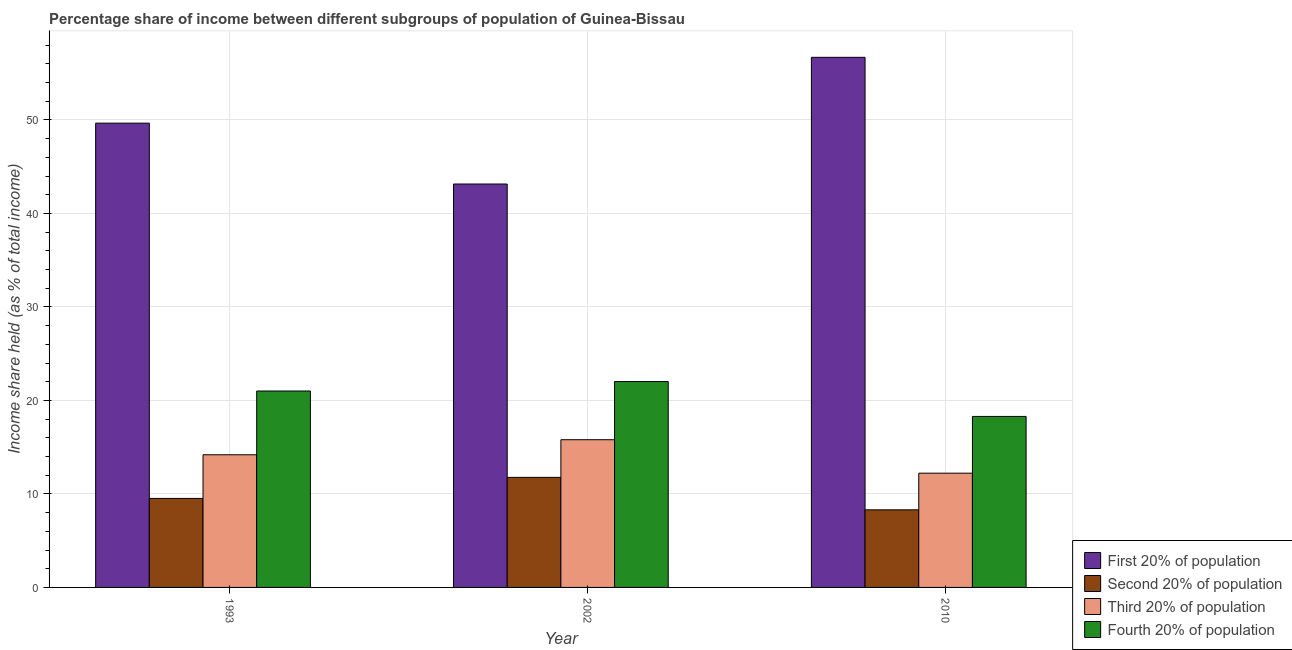How many different coloured bars are there?
Make the answer very short. 4. Are the number of bars per tick equal to the number of legend labels?
Offer a very short reply. Yes. Are the number of bars on each tick of the X-axis equal?
Offer a terse response. Yes. How many bars are there on the 2nd tick from the right?
Give a very brief answer. 4. In how many cases, is the number of bars for a given year not equal to the number of legend labels?
Offer a terse response. 0. What is the share of the income held by first 20% of the population in 2002?
Keep it short and to the point. 43.15. Across all years, what is the maximum share of the income held by first 20% of the population?
Offer a terse response. 56.7. Across all years, what is the minimum share of the income held by fourth 20% of the population?
Your response must be concise. 18.29. In which year was the share of the income held by second 20% of the population minimum?
Offer a very short reply. 2010. What is the total share of the income held by second 20% of the population in the graph?
Provide a short and direct response. 29.59. What is the difference between the share of the income held by fourth 20% of the population in 1993 and that in 2010?
Your answer should be compact. 2.72. What is the difference between the share of the income held by fourth 20% of the population in 2010 and the share of the income held by third 20% of the population in 2002?
Your answer should be compact. -3.73. What is the average share of the income held by second 20% of the population per year?
Keep it short and to the point. 9.86. In the year 2010, what is the difference between the share of the income held by third 20% of the population and share of the income held by fourth 20% of the population?
Make the answer very short. 0. What is the ratio of the share of the income held by third 20% of the population in 1993 to that in 2002?
Offer a terse response. 0.9. What is the difference between the highest and the second highest share of the income held by third 20% of the population?
Your response must be concise. 1.61. What is the difference between the highest and the lowest share of the income held by first 20% of the population?
Ensure brevity in your answer.  13.55. Is the sum of the share of the income held by second 20% of the population in 2002 and 2010 greater than the maximum share of the income held by third 20% of the population across all years?
Make the answer very short. Yes. What does the 4th bar from the left in 2002 represents?
Ensure brevity in your answer.  Fourth 20% of population. What does the 1st bar from the right in 1993 represents?
Ensure brevity in your answer.  Fourth 20% of population. Is it the case that in every year, the sum of the share of the income held by first 20% of the population and share of the income held by second 20% of the population is greater than the share of the income held by third 20% of the population?
Offer a terse response. Yes. How many bars are there?
Provide a short and direct response. 12. Are all the bars in the graph horizontal?
Offer a terse response. No. Are the values on the major ticks of Y-axis written in scientific E-notation?
Make the answer very short. No. Does the graph contain any zero values?
Your response must be concise. No. Does the graph contain grids?
Offer a terse response. Yes. Where does the legend appear in the graph?
Give a very brief answer. Bottom right. How many legend labels are there?
Offer a very short reply. 4. How are the legend labels stacked?
Provide a short and direct response. Vertical. What is the title of the graph?
Keep it short and to the point. Percentage share of income between different subgroups of population of Guinea-Bissau. Does "Quality of public administration" appear as one of the legend labels in the graph?
Give a very brief answer. No. What is the label or title of the X-axis?
Make the answer very short. Year. What is the label or title of the Y-axis?
Give a very brief answer. Income share held (as % of total income). What is the Income share held (as % of total income) of First 20% of population in 1993?
Offer a terse response. 49.66. What is the Income share held (as % of total income) in Second 20% of population in 1993?
Provide a succinct answer. 9.52. What is the Income share held (as % of total income) in Third 20% of population in 1993?
Give a very brief answer. 14.19. What is the Income share held (as % of total income) in Fourth 20% of population in 1993?
Your answer should be very brief. 21.01. What is the Income share held (as % of total income) in First 20% of population in 2002?
Offer a terse response. 43.15. What is the Income share held (as % of total income) in Second 20% of population in 2002?
Keep it short and to the point. 11.77. What is the Income share held (as % of total income) in Third 20% of population in 2002?
Provide a succinct answer. 15.8. What is the Income share held (as % of total income) of Fourth 20% of population in 2002?
Make the answer very short. 22.02. What is the Income share held (as % of total income) in First 20% of population in 2010?
Offer a very short reply. 56.7. What is the Income share held (as % of total income) in Second 20% of population in 2010?
Your response must be concise. 8.3. What is the Income share held (as % of total income) of Third 20% of population in 2010?
Provide a short and direct response. 12.22. What is the Income share held (as % of total income) in Fourth 20% of population in 2010?
Make the answer very short. 18.29. Across all years, what is the maximum Income share held (as % of total income) of First 20% of population?
Give a very brief answer. 56.7. Across all years, what is the maximum Income share held (as % of total income) of Second 20% of population?
Provide a short and direct response. 11.77. Across all years, what is the maximum Income share held (as % of total income) in Fourth 20% of population?
Keep it short and to the point. 22.02. Across all years, what is the minimum Income share held (as % of total income) in First 20% of population?
Your answer should be very brief. 43.15. Across all years, what is the minimum Income share held (as % of total income) in Second 20% of population?
Your response must be concise. 8.3. Across all years, what is the minimum Income share held (as % of total income) in Third 20% of population?
Provide a succinct answer. 12.22. Across all years, what is the minimum Income share held (as % of total income) in Fourth 20% of population?
Ensure brevity in your answer.  18.29. What is the total Income share held (as % of total income) of First 20% of population in the graph?
Make the answer very short. 149.51. What is the total Income share held (as % of total income) of Second 20% of population in the graph?
Provide a short and direct response. 29.59. What is the total Income share held (as % of total income) in Third 20% of population in the graph?
Give a very brief answer. 42.21. What is the total Income share held (as % of total income) in Fourth 20% of population in the graph?
Offer a terse response. 61.32. What is the difference between the Income share held (as % of total income) of First 20% of population in 1993 and that in 2002?
Offer a terse response. 6.51. What is the difference between the Income share held (as % of total income) of Second 20% of population in 1993 and that in 2002?
Provide a short and direct response. -2.25. What is the difference between the Income share held (as % of total income) of Third 20% of population in 1993 and that in 2002?
Make the answer very short. -1.61. What is the difference between the Income share held (as % of total income) of Fourth 20% of population in 1993 and that in 2002?
Your answer should be very brief. -1.01. What is the difference between the Income share held (as % of total income) of First 20% of population in 1993 and that in 2010?
Your answer should be very brief. -7.04. What is the difference between the Income share held (as % of total income) of Second 20% of population in 1993 and that in 2010?
Give a very brief answer. 1.22. What is the difference between the Income share held (as % of total income) of Third 20% of population in 1993 and that in 2010?
Offer a terse response. 1.97. What is the difference between the Income share held (as % of total income) of Fourth 20% of population in 1993 and that in 2010?
Offer a terse response. 2.72. What is the difference between the Income share held (as % of total income) of First 20% of population in 2002 and that in 2010?
Provide a succinct answer. -13.55. What is the difference between the Income share held (as % of total income) in Second 20% of population in 2002 and that in 2010?
Your answer should be very brief. 3.47. What is the difference between the Income share held (as % of total income) of Third 20% of population in 2002 and that in 2010?
Keep it short and to the point. 3.58. What is the difference between the Income share held (as % of total income) of Fourth 20% of population in 2002 and that in 2010?
Your response must be concise. 3.73. What is the difference between the Income share held (as % of total income) in First 20% of population in 1993 and the Income share held (as % of total income) in Second 20% of population in 2002?
Offer a terse response. 37.89. What is the difference between the Income share held (as % of total income) in First 20% of population in 1993 and the Income share held (as % of total income) in Third 20% of population in 2002?
Give a very brief answer. 33.86. What is the difference between the Income share held (as % of total income) in First 20% of population in 1993 and the Income share held (as % of total income) in Fourth 20% of population in 2002?
Give a very brief answer. 27.64. What is the difference between the Income share held (as % of total income) in Second 20% of population in 1993 and the Income share held (as % of total income) in Third 20% of population in 2002?
Give a very brief answer. -6.28. What is the difference between the Income share held (as % of total income) in Second 20% of population in 1993 and the Income share held (as % of total income) in Fourth 20% of population in 2002?
Provide a short and direct response. -12.5. What is the difference between the Income share held (as % of total income) of Third 20% of population in 1993 and the Income share held (as % of total income) of Fourth 20% of population in 2002?
Offer a terse response. -7.83. What is the difference between the Income share held (as % of total income) of First 20% of population in 1993 and the Income share held (as % of total income) of Second 20% of population in 2010?
Make the answer very short. 41.36. What is the difference between the Income share held (as % of total income) of First 20% of population in 1993 and the Income share held (as % of total income) of Third 20% of population in 2010?
Offer a terse response. 37.44. What is the difference between the Income share held (as % of total income) in First 20% of population in 1993 and the Income share held (as % of total income) in Fourth 20% of population in 2010?
Your answer should be compact. 31.37. What is the difference between the Income share held (as % of total income) of Second 20% of population in 1993 and the Income share held (as % of total income) of Fourth 20% of population in 2010?
Give a very brief answer. -8.77. What is the difference between the Income share held (as % of total income) in First 20% of population in 2002 and the Income share held (as % of total income) in Second 20% of population in 2010?
Offer a very short reply. 34.85. What is the difference between the Income share held (as % of total income) of First 20% of population in 2002 and the Income share held (as % of total income) of Third 20% of population in 2010?
Make the answer very short. 30.93. What is the difference between the Income share held (as % of total income) in First 20% of population in 2002 and the Income share held (as % of total income) in Fourth 20% of population in 2010?
Offer a terse response. 24.86. What is the difference between the Income share held (as % of total income) of Second 20% of population in 2002 and the Income share held (as % of total income) of Third 20% of population in 2010?
Offer a very short reply. -0.45. What is the difference between the Income share held (as % of total income) of Second 20% of population in 2002 and the Income share held (as % of total income) of Fourth 20% of population in 2010?
Make the answer very short. -6.52. What is the difference between the Income share held (as % of total income) of Third 20% of population in 2002 and the Income share held (as % of total income) of Fourth 20% of population in 2010?
Your response must be concise. -2.49. What is the average Income share held (as % of total income) in First 20% of population per year?
Ensure brevity in your answer.  49.84. What is the average Income share held (as % of total income) of Second 20% of population per year?
Your answer should be compact. 9.86. What is the average Income share held (as % of total income) in Third 20% of population per year?
Offer a terse response. 14.07. What is the average Income share held (as % of total income) in Fourth 20% of population per year?
Provide a short and direct response. 20.44. In the year 1993, what is the difference between the Income share held (as % of total income) in First 20% of population and Income share held (as % of total income) in Second 20% of population?
Keep it short and to the point. 40.14. In the year 1993, what is the difference between the Income share held (as % of total income) of First 20% of population and Income share held (as % of total income) of Third 20% of population?
Offer a terse response. 35.47. In the year 1993, what is the difference between the Income share held (as % of total income) of First 20% of population and Income share held (as % of total income) of Fourth 20% of population?
Offer a very short reply. 28.65. In the year 1993, what is the difference between the Income share held (as % of total income) in Second 20% of population and Income share held (as % of total income) in Third 20% of population?
Give a very brief answer. -4.67. In the year 1993, what is the difference between the Income share held (as % of total income) in Second 20% of population and Income share held (as % of total income) in Fourth 20% of population?
Your response must be concise. -11.49. In the year 1993, what is the difference between the Income share held (as % of total income) of Third 20% of population and Income share held (as % of total income) of Fourth 20% of population?
Ensure brevity in your answer.  -6.82. In the year 2002, what is the difference between the Income share held (as % of total income) of First 20% of population and Income share held (as % of total income) of Second 20% of population?
Offer a terse response. 31.38. In the year 2002, what is the difference between the Income share held (as % of total income) of First 20% of population and Income share held (as % of total income) of Third 20% of population?
Your answer should be very brief. 27.35. In the year 2002, what is the difference between the Income share held (as % of total income) of First 20% of population and Income share held (as % of total income) of Fourth 20% of population?
Your response must be concise. 21.13. In the year 2002, what is the difference between the Income share held (as % of total income) in Second 20% of population and Income share held (as % of total income) in Third 20% of population?
Your response must be concise. -4.03. In the year 2002, what is the difference between the Income share held (as % of total income) in Second 20% of population and Income share held (as % of total income) in Fourth 20% of population?
Your answer should be compact. -10.25. In the year 2002, what is the difference between the Income share held (as % of total income) of Third 20% of population and Income share held (as % of total income) of Fourth 20% of population?
Your answer should be compact. -6.22. In the year 2010, what is the difference between the Income share held (as % of total income) in First 20% of population and Income share held (as % of total income) in Second 20% of population?
Make the answer very short. 48.4. In the year 2010, what is the difference between the Income share held (as % of total income) in First 20% of population and Income share held (as % of total income) in Third 20% of population?
Provide a short and direct response. 44.48. In the year 2010, what is the difference between the Income share held (as % of total income) of First 20% of population and Income share held (as % of total income) of Fourth 20% of population?
Provide a short and direct response. 38.41. In the year 2010, what is the difference between the Income share held (as % of total income) in Second 20% of population and Income share held (as % of total income) in Third 20% of population?
Offer a very short reply. -3.92. In the year 2010, what is the difference between the Income share held (as % of total income) of Second 20% of population and Income share held (as % of total income) of Fourth 20% of population?
Your response must be concise. -9.99. In the year 2010, what is the difference between the Income share held (as % of total income) in Third 20% of population and Income share held (as % of total income) in Fourth 20% of population?
Give a very brief answer. -6.07. What is the ratio of the Income share held (as % of total income) in First 20% of population in 1993 to that in 2002?
Your response must be concise. 1.15. What is the ratio of the Income share held (as % of total income) in Second 20% of population in 1993 to that in 2002?
Your response must be concise. 0.81. What is the ratio of the Income share held (as % of total income) of Third 20% of population in 1993 to that in 2002?
Your answer should be very brief. 0.9. What is the ratio of the Income share held (as % of total income) in Fourth 20% of population in 1993 to that in 2002?
Offer a very short reply. 0.95. What is the ratio of the Income share held (as % of total income) of First 20% of population in 1993 to that in 2010?
Make the answer very short. 0.88. What is the ratio of the Income share held (as % of total income) in Second 20% of population in 1993 to that in 2010?
Your answer should be compact. 1.15. What is the ratio of the Income share held (as % of total income) of Third 20% of population in 1993 to that in 2010?
Your response must be concise. 1.16. What is the ratio of the Income share held (as % of total income) of Fourth 20% of population in 1993 to that in 2010?
Provide a short and direct response. 1.15. What is the ratio of the Income share held (as % of total income) of First 20% of population in 2002 to that in 2010?
Provide a short and direct response. 0.76. What is the ratio of the Income share held (as % of total income) in Second 20% of population in 2002 to that in 2010?
Keep it short and to the point. 1.42. What is the ratio of the Income share held (as % of total income) of Third 20% of population in 2002 to that in 2010?
Ensure brevity in your answer.  1.29. What is the ratio of the Income share held (as % of total income) of Fourth 20% of population in 2002 to that in 2010?
Your answer should be very brief. 1.2. What is the difference between the highest and the second highest Income share held (as % of total income) of First 20% of population?
Keep it short and to the point. 7.04. What is the difference between the highest and the second highest Income share held (as % of total income) in Second 20% of population?
Offer a terse response. 2.25. What is the difference between the highest and the second highest Income share held (as % of total income) in Third 20% of population?
Your answer should be very brief. 1.61. What is the difference between the highest and the second highest Income share held (as % of total income) of Fourth 20% of population?
Keep it short and to the point. 1.01. What is the difference between the highest and the lowest Income share held (as % of total income) in First 20% of population?
Ensure brevity in your answer.  13.55. What is the difference between the highest and the lowest Income share held (as % of total income) in Second 20% of population?
Make the answer very short. 3.47. What is the difference between the highest and the lowest Income share held (as % of total income) of Third 20% of population?
Give a very brief answer. 3.58. What is the difference between the highest and the lowest Income share held (as % of total income) of Fourth 20% of population?
Provide a short and direct response. 3.73. 